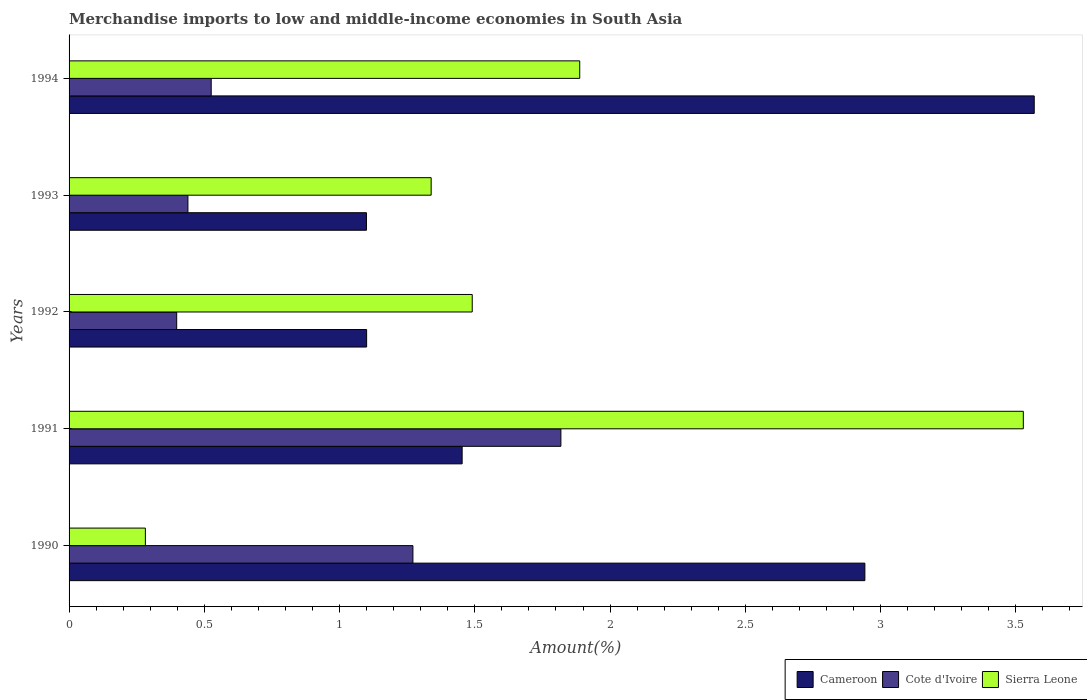How many bars are there on the 2nd tick from the top?
Ensure brevity in your answer.  3. What is the label of the 2nd group of bars from the top?
Ensure brevity in your answer.  1993. What is the percentage of amount earned from merchandise imports in Sierra Leone in 1994?
Ensure brevity in your answer.  1.89. Across all years, what is the maximum percentage of amount earned from merchandise imports in Sierra Leone?
Your answer should be very brief. 3.53. Across all years, what is the minimum percentage of amount earned from merchandise imports in Sierra Leone?
Offer a terse response. 0.28. What is the total percentage of amount earned from merchandise imports in Cameroon in the graph?
Keep it short and to the point. 10.16. What is the difference between the percentage of amount earned from merchandise imports in Sierra Leone in 1990 and that in 1992?
Your answer should be very brief. -1.21. What is the difference between the percentage of amount earned from merchandise imports in Cameroon in 1992 and the percentage of amount earned from merchandise imports in Cote d'Ivoire in 1993?
Ensure brevity in your answer.  0.66. What is the average percentage of amount earned from merchandise imports in Cameroon per year?
Offer a very short reply. 2.03. In the year 1993, what is the difference between the percentage of amount earned from merchandise imports in Cote d'Ivoire and percentage of amount earned from merchandise imports in Sierra Leone?
Provide a short and direct response. -0.9. What is the ratio of the percentage of amount earned from merchandise imports in Sierra Leone in 1990 to that in 1993?
Make the answer very short. 0.21. Is the percentage of amount earned from merchandise imports in Sierra Leone in 1990 less than that in 1994?
Make the answer very short. Yes. Is the difference between the percentage of amount earned from merchandise imports in Cote d'Ivoire in 1991 and 1994 greater than the difference between the percentage of amount earned from merchandise imports in Sierra Leone in 1991 and 1994?
Ensure brevity in your answer.  No. What is the difference between the highest and the second highest percentage of amount earned from merchandise imports in Sierra Leone?
Offer a very short reply. 1.64. What is the difference between the highest and the lowest percentage of amount earned from merchandise imports in Cote d'Ivoire?
Your answer should be compact. 1.42. In how many years, is the percentage of amount earned from merchandise imports in Cote d'Ivoire greater than the average percentage of amount earned from merchandise imports in Cote d'Ivoire taken over all years?
Keep it short and to the point. 2. Is the sum of the percentage of amount earned from merchandise imports in Sierra Leone in 1992 and 1993 greater than the maximum percentage of amount earned from merchandise imports in Cote d'Ivoire across all years?
Offer a terse response. Yes. What does the 3rd bar from the top in 1992 represents?
Keep it short and to the point. Cameroon. What does the 1st bar from the bottom in 1993 represents?
Your answer should be very brief. Cameroon. How many bars are there?
Keep it short and to the point. 15. How many years are there in the graph?
Make the answer very short. 5. Does the graph contain any zero values?
Your answer should be compact. No. How are the legend labels stacked?
Your answer should be compact. Horizontal. What is the title of the graph?
Provide a succinct answer. Merchandise imports to low and middle-income economies in South Asia. Does "Sri Lanka" appear as one of the legend labels in the graph?
Keep it short and to the point. No. What is the label or title of the X-axis?
Provide a short and direct response. Amount(%). What is the label or title of the Y-axis?
Your answer should be very brief. Years. What is the Amount(%) of Cameroon in 1990?
Ensure brevity in your answer.  2.94. What is the Amount(%) in Cote d'Ivoire in 1990?
Ensure brevity in your answer.  1.27. What is the Amount(%) of Sierra Leone in 1990?
Your response must be concise. 0.28. What is the Amount(%) of Cameroon in 1991?
Provide a short and direct response. 1.45. What is the Amount(%) in Cote d'Ivoire in 1991?
Your response must be concise. 1.82. What is the Amount(%) in Sierra Leone in 1991?
Your response must be concise. 3.53. What is the Amount(%) in Cameroon in 1992?
Offer a very short reply. 1.1. What is the Amount(%) of Cote d'Ivoire in 1992?
Make the answer very short. 0.4. What is the Amount(%) of Sierra Leone in 1992?
Offer a terse response. 1.49. What is the Amount(%) in Cameroon in 1993?
Offer a very short reply. 1.1. What is the Amount(%) in Cote d'Ivoire in 1993?
Your answer should be very brief. 0.44. What is the Amount(%) of Sierra Leone in 1993?
Provide a succinct answer. 1.34. What is the Amount(%) in Cameroon in 1994?
Ensure brevity in your answer.  3.57. What is the Amount(%) in Cote d'Ivoire in 1994?
Provide a short and direct response. 0.53. What is the Amount(%) in Sierra Leone in 1994?
Ensure brevity in your answer.  1.89. Across all years, what is the maximum Amount(%) in Cameroon?
Your answer should be compact. 3.57. Across all years, what is the maximum Amount(%) in Cote d'Ivoire?
Provide a short and direct response. 1.82. Across all years, what is the maximum Amount(%) in Sierra Leone?
Provide a short and direct response. 3.53. Across all years, what is the minimum Amount(%) in Cameroon?
Provide a succinct answer. 1.1. Across all years, what is the minimum Amount(%) of Cote d'Ivoire?
Your answer should be compact. 0.4. Across all years, what is the minimum Amount(%) of Sierra Leone?
Keep it short and to the point. 0.28. What is the total Amount(%) of Cameroon in the graph?
Your answer should be compact. 10.16. What is the total Amount(%) of Cote d'Ivoire in the graph?
Offer a terse response. 4.45. What is the total Amount(%) in Sierra Leone in the graph?
Keep it short and to the point. 8.53. What is the difference between the Amount(%) of Cameroon in 1990 and that in 1991?
Give a very brief answer. 1.49. What is the difference between the Amount(%) in Cote d'Ivoire in 1990 and that in 1991?
Ensure brevity in your answer.  -0.55. What is the difference between the Amount(%) of Sierra Leone in 1990 and that in 1991?
Offer a terse response. -3.25. What is the difference between the Amount(%) in Cameroon in 1990 and that in 1992?
Make the answer very short. 1.84. What is the difference between the Amount(%) of Cote d'Ivoire in 1990 and that in 1992?
Give a very brief answer. 0.87. What is the difference between the Amount(%) in Sierra Leone in 1990 and that in 1992?
Make the answer very short. -1.21. What is the difference between the Amount(%) in Cameroon in 1990 and that in 1993?
Keep it short and to the point. 1.84. What is the difference between the Amount(%) of Cote d'Ivoire in 1990 and that in 1993?
Ensure brevity in your answer.  0.83. What is the difference between the Amount(%) of Sierra Leone in 1990 and that in 1993?
Your response must be concise. -1.06. What is the difference between the Amount(%) of Cameroon in 1990 and that in 1994?
Your answer should be compact. -0.63. What is the difference between the Amount(%) of Cote d'Ivoire in 1990 and that in 1994?
Your answer should be very brief. 0.75. What is the difference between the Amount(%) of Sierra Leone in 1990 and that in 1994?
Your answer should be very brief. -1.61. What is the difference between the Amount(%) in Cameroon in 1991 and that in 1992?
Offer a terse response. 0.35. What is the difference between the Amount(%) of Cote d'Ivoire in 1991 and that in 1992?
Ensure brevity in your answer.  1.42. What is the difference between the Amount(%) of Sierra Leone in 1991 and that in 1992?
Offer a terse response. 2.04. What is the difference between the Amount(%) in Cameroon in 1991 and that in 1993?
Your answer should be compact. 0.35. What is the difference between the Amount(%) of Cote d'Ivoire in 1991 and that in 1993?
Provide a short and direct response. 1.38. What is the difference between the Amount(%) in Sierra Leone in 1991 and that in 1993?
Your response must be concise. 2.19. What is the difference between the Amount(%) of Cameroon in 1991 and that in 1994?
Provide a short and direct response. -2.12. What is the difference between the Amount(%) of Cote d'Ivoire in 1991 and that in 1994?
Ensure brevity in your answer.  1.29. What is the difference between the Amount(%) in Sierra Leone in 1991 and that in 1994?
Give a very brief answer. 1.64. What is the difference between the Amount(%) of Cameroon in 1992 and that in 1993?
Your answer should be very brief. 0. What is the difference between the Amount(%) in Cote d'Ivoire in 1992 and that in 1993?
Your answer should be very brief. -0.04. What is the difference between the Amount(%) in Sierra Leone in 1992 and that in 1993?
Offer a very short reply. 0.15. What is the difference between the Amount(%) in Cameroon in 1992 and that in 1994?
Keep it short and to the point. -2.47. What is the difference between the Amount(%) of Cote d'Ivoire in 1992 and that in 1994?
Your answer should be very brief. -0.13. What is the difference between the Amount(%) of Sierra Leone in 1992 and that in 1994?
Give a very brief answer. -0.4. What is the difference between the Amount(%) of Cameroon in 1993 and that in 1994?
Offer a very short reply. -2.47. What is the difference between the Amount(%) of Cote d'Ivoire in 1993 and that in 1994?
Keep it short and to the point. -0.09. What is the difference between the Amount(%) of Sierra Leone in 1993 and that in 1994?
Provide a short and direct response. -0.55. What is the difference between the Amount(%) in Cameroon in 1990 and the Amount(%) in Cote d'Ivoire in 1991?
Your response must be concise. 1.12. What is the difference between the Amount(%) in Cameroon in 1990 and the Amount(%) in Sierra Leone in 1991?
Keep it short and to the point. -0.59. What is the difference between the Amount(%) of Cote d'Ivoire in 1990 and the Amount(%) of Sierra Leone in 1991?
Your answer should be compact. -2.26. What is the difference between the Amount(%) in Cameroon in 1990 and the Amount(%) in Cote d'Ivoire in 1992?
Keep it short and to the point. 2.54. What is the difference between the Amount(%) in Cameroon in 1990 and the Amount(%) in Sierra Leone in 1992?
Keep it short and to the point. 1.45. What is the difference between the Amount(%) in Cote d'Ivoire in 1990 and the Amount(%) in Sierra Leone in 1992?
Ensure brevity in your answer.  -0.22. What is the difference between the Amount(%) of Cameroon in 1990 and the Amount(%) of Cote d'Ivoire in 1993?
Make the answer very short. 2.5. What is the difference between the Amount(%) in Cameroon in 1990 and the Amount(%) in Sierra Leone in 1993?
Provide a short and direct response. 1.6. What is the difference between the Amount(%) of Cote d'Ivoire in 1990 and the Amount(%) of Sierra Leone in 1993?
Provide a succinct answer. -0.07. What is the difference between the Amount(%) in Cameroon in 1990 and the Amount(%) in Cote d'Ivoire in 1994?
Provide a short and direct response. 2.42. What is the difference between the Amount(%) of Cameroon in 1990 and the Amount(%) of Sierra Leone in 1994?
Ensure brevity in your answer.  1.05. What is the difference between the Amount(%) of Cote d'Ivoire in 1990 and the Amount(%) of Sierra Leone in 1994?
Your answer should be compact. -0.62. What is the difference between the Amount(%) in Cameroon in 1991 and the Amount(%) in Cote d'Ivoire in 1992?
Ensure brevity in your answer.  1.06. What is the difference between the Amount(%) of Cameroon in 1991 and the Amount(%) of Sierra Leone in 1992?
Make the answer very short. -0.04. What is the difference between the Amount(%) of Cote d'Ivoire in 1991 and the Amount(%) of Sierra Leone in 1992?
Your response must be concise. 0.33. What is the difference between the Amount(%) in Cameroon in 1991 and the Amount(%) in Cote d'Ivoire in 1993?
Ensure brevity in your answer.  1.01. What is the difference between the Amount(%) of Cameroon in 1991 and the Amount(%) of Sierra Leone in 1993?
Your response must be concise. 0.11. What is the difference between the Amount(%) in Cote d'Ivoire in 1991 and the Amount(%) in Sierra Leone in 1993?
Keep it short and to the point. 0.48. What is the difference between the Amount(%) in Cameroon in 1991 and the Amount(%) in Cote d'Ivoire in 1994?
Provide a succinct answer. 0.93. What is the difference between the Amount(%) in Cameroon in 1991 and the Amount(%) in Sierra Leone in 1994?
Your response must be concise. -0.43. What is the difference between the Amount(%) in Cote d'Ivoire in 1991 and the Amount(%) in Sierra Leone in 1994?
Ensure brevity in your answer.  -0.07. What is the difference between the Amount(%) in Cameroon in 1992 and the Amount(%) in Cote d'Ivoire in 1993?
Your response must be concise. 0.66. What is the difference between the Amount(%) of Cameroon in 1992 and the Amount(%) of Sierra Leone in 1993?
Make the answer very short. -0.24. What is the difference between the Amount(%) in Cote d'Ivoire in 1992 and the Amount(%) in Sierra Leone in 1993?
Make the answer very short. -0.94. What is the difference between the Amount(%) in Cameroon in 1992 and the Amount(%) in Cote d'Ivoire in 1994?
Offer a terse response. 0.57. What is the difference between the Amount(%) in Cameroon in 1992 and the Amount(%) in Sierra Leone in 1994?
Your answer should be very brief. -0.79. What is the difference between the Amount(%) of Cote d'Ivoire in 1992 and the Amount(%) of Sierra Leone in 1994?
Offer a very short reply. -1.49. What is the difference between the Amount(%) in Cameroon in 1993 and the Amount(%) in Cote d'Ivoire in 1994?
Keep it short and to the point. 0.57. What is the difference between the Amount(%) in Cameroon in 1993 and the Amount(%) in Sierra Leone in 1994?
Offer a terse response. -0.79. What is the difference between the Amount(%) in Cote d'Ivoire in 1993 and the Amount(%) in Sierra Leone in 1994?
Make the answer very short. -1.45. What is the average Amount(%) of Cameroon per year?
Make the answer very short. 2.03. What is the average Amount(%) in Cote d'Ivoire per year?
Offer a very short reply. 0.89. What is the average Amount(%) of Sierra Leone per year?
Keep it short and to the point. 1.71. In the year 1990, what is the difference between the Amount(%) in Cameroon and Amount(%) in Cote d'Ivoire?
Make the answer very short. 1.67. In the year 1990, what is the difference between the Amount(%) of Cameroon and Amount(%) of Sierra Leone?
Make the answer very short. 2.66. In the year 1991, what is the difference between the Amount(%) in Cameroon and Amount(%) in Cote d'Ivoire?
Provide a succinct answer. -0.37. In the year 1991, what is the difference between the Amount(%) in Cameroon and Amount(%) in Sierra Leone?
Your answer should be very brief. -2.07. In the year 1991, what is the difference between the Amount(%) in Cote d'Ivoire and Amount(%) in Sierra Leone?
Ensure brevity in your answer.  -1.71. In the year 1992, what is the difference between the Amount(%) of Cameroon and Amount(%) of Cote d'Ivoire?
Your response must be concise. 0.7. In the year 1992, what is the difference between the Amount(%) in Cameroon and Amount(%) in Sierra Leone?
Offer a very short reply. -0.39. In the year 1992, what is the difference between the Amount(%) of Cote d'Ivoire and Amount(%) of Sierra Leone?
Offer a terse response. -1.09. In the year 1993, what is the difference between the Amount(%) of Cameroon and Amount(%) of Cote d'Ivoire?
Ensure brevity in your answer.  0.66. In the year 1993, what is the difference between the Amount(%) of Cameroon and Amount(%) of Sierra Leone?
Ensure brevity in your answer.  -0.24. In the year 1993, what is the difference between the Amount(%) of Cote d'Ivoire and Amount(%) of Sierra Leone?
Offer a very short reply. -0.9. In the year 1994, what is the difference between the Amount(%) in Cameroon and Amount(%) in Cote d'Ivoire?
Ensure brevity in your answer.  3.04. In the year 1994, what is the difference between the Amount(%) in Cameroon and Amount(%) in Sierra Leone?
Your answer should be very brief. 1.68. In the year 1994, what is the difference between the Amount(%) in Cote d'Ivoire and Amount(%) in Sierra Leone?
Your answer should be very brief. -1.36. What is the ratio of the Amount(%) in Cameroon in 1990 to that in 1991?
Offer a very short reply. 2.02. What is the ratio of the Amount(%) in Cote d'Ivoire in 1990 to that in 1991?
Ensure brevity in your answer.  0.7. What is the ratio of the Amount(%) of Sierra Leone in 1990 to that in 1991?
Your response must be concise. 0.08. What is the ratio of the Amount(%) in Cameroon in 1990 to that in 1992?
Your answer should be very brief. 2.67. What is the ratio of the Amount(%) of Cote d'Ivoire in 1990 to that in 1992?
Your response must be concise. 3.2. What is the ratio of the Amount(%) of Sierra Leone in 1990 to that in 1992?
Offer a very short reply. 0.19. What is the ratio of the Amount(%) in Cameroon in 1990 to that in 1993?
Ensure brevity in your answer.  2.68. What is the ratio of the Amount(%) of Cote d'Ivoire in 1990 to that in 1993?
Offer a terse response. 2.89. What is the ratio of the Amount(%) in Sierra Leone in 1990 to that in 1993?
Your answer should be compact. 0.21. What is the ratio of the Amount(%) of Cameroon in 1990 to that in 1994?
Keep it short and to the point. 0.82. What is the ratio of the Amount(%) in Cote d'Ivoire in 1990 to that in 1994?
Your response must be concise. 2.42. What is the ratio of the Amount(%) of Sierra Leone in 1990 to that in 1994?
Provide a short and direct response. 0.15. What is the ratio of the Amount(%) of Cameroon in 1991 to that in 1992?
Keep it short and to the point. 1.32. What is the ratio of the Amount(%) in Cote d'Ivoire in 1991 to that in 1992?
Keep it short and to the point. 4.57. What is the ratio of the Amount(%) of Sierra Leone in 1991 to that in 1992?
Ensure brevity in your answer.  2.37. What is the ratio of the Amount(%) in Cameroon in 1991 to that in 1993?
Ensure brevity in your answer.  1.32. What is the ratio of the Amount(%) of Cote d'Ivoire in 1991 to that in 1993?
Your answer should be compact. 4.14. What is the ratio of the Amount(%) of Sierra Leone in 1991 to that in 1993?
Provide a succinct answer. 2.64. What is the ratio of the Amount(%) in Cameroon in 1991 to that in 1994?
Offer a terse response. 0.41. What is the ratio of the Amount(%) of Cote d'Ivoire in 1991 to that in 1994?
Keep it short and to the point. 3.46. What is the ratio of the Amount(%) of Sierra Leone in 1991 to that in 1994?
Your response must be concise. 1.87. What is the ratio of the Amount(%) in Cameroon in 1992 to that in 1993?
Offer a terse response. 1. What is the ratio of the Amount(%) of Cote d'Ivoire in 1992 to that in 1993?
Make the answer very short. 0.91. What is the ratio of the Amount(%) in Sierra Leone in 1992 to that in 1993?
Your answer should be compact. 1.11. What is the ratio of the Amount(%) of Cameroon in 1992 to that in 1994?
Your answer should be very brief. 0.31. What is the ratio of the Amount(%) in Cote d'Ivoire in 1992 to that in 1994?
Give a very brief answer. 0.76. What is the ratio of the Amount(%) in Sierra Leone in 1992 to that in 1994?
Provide a succinct answer. 0.79. What is the ratio of the Amount(%) of Cameroon in 1993 to that in 1994?
Your answer should be very brief. 0.31. What is the ratio of the Amount(%) of Cote d'Ivoire in 1993 to that in 1994?
Provide a succinct answer. 0.84. What is the ratio of the Amount(%) in Sierra Leone in 1993 to that in 1994?
Your answer should be compact. 0.71. What is the difference between the highest and the second highest Amount(%) of Cameroon?
Ensure brevity in your answer.  0.63. What is the difference between the highest and the second highest Amount(%) of Cote d'Ivoire?
Your answer should be very brief. 0.55. What is the difference between the highest and the second highest Amount(%) in Sierra Leone?
Provide a short and direct response. 1.64. What is the difference between the highest and the lowest Amount(%) of Cameroon?
Your response must be concise. 2.47. What is the difference between the highest and the lowest Amount(%) in Cote d'Ivoire?
Your answer should be very brief. 1.42. What is the difference between the highest and the lowest Amount(%) of Sierra Leone?
Your answer should be compact. 3.25. 